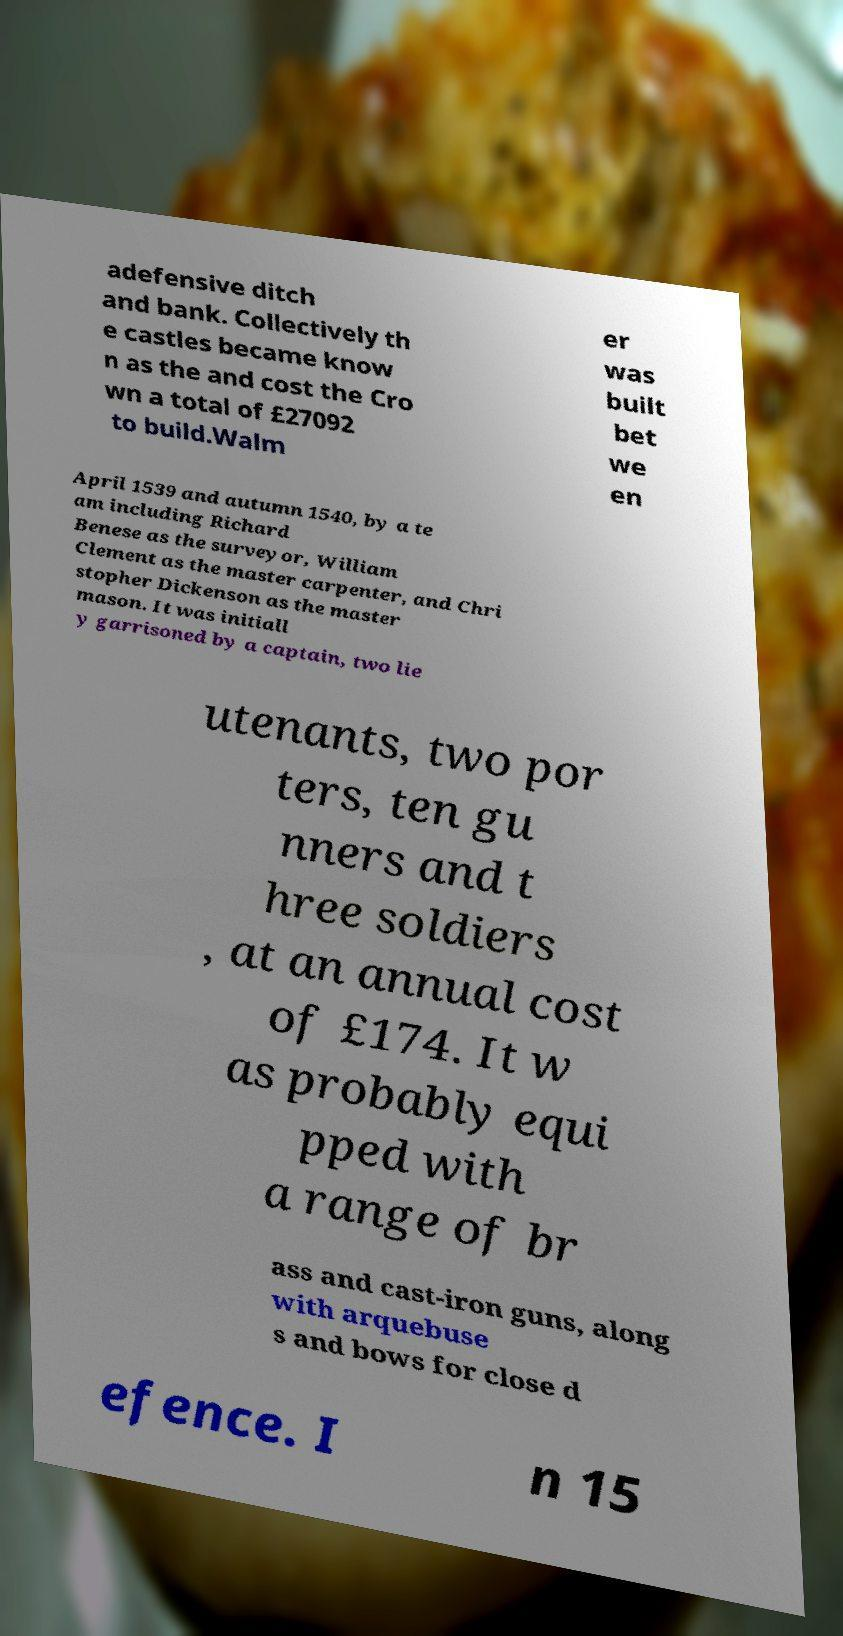For documentation purposes, I need the text within this image transcribed. Could you provide that? adefensive ditch and bank. Collectively th e castles became know n as the and cost the Cro wn a total of £27092 to build.Walm er was built bet we en April 1539 and autumn 1540, by a te am including Richard Benese as the surveyor, William Clement as the master carpenter, and Chri stopher Dickenson as the master mason. It was initiall y garrisoned by a captain, two lie utenants, two por ters, ten gu nners and t hree soldiers , at an annual cost of £174. It w as probably equi pped with a range of br ass and cast-iron guns, along with arquebuse s and bows for close d efence. I n 15 